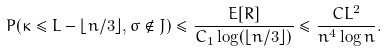<formula> <loc_0><loc_0><loc_500><loc_500>P ( \kappa \leq L - \lfloor n / 3 \rfloor , \sigma \notin J ) \leq \frac { E [ R ] } { C _ { 1 } \log ( \lfloor n / 3 \rfloor ) } \leq \frac { C L ^ { 2 } } { n ^ { 4 } \log n } .</formula> 